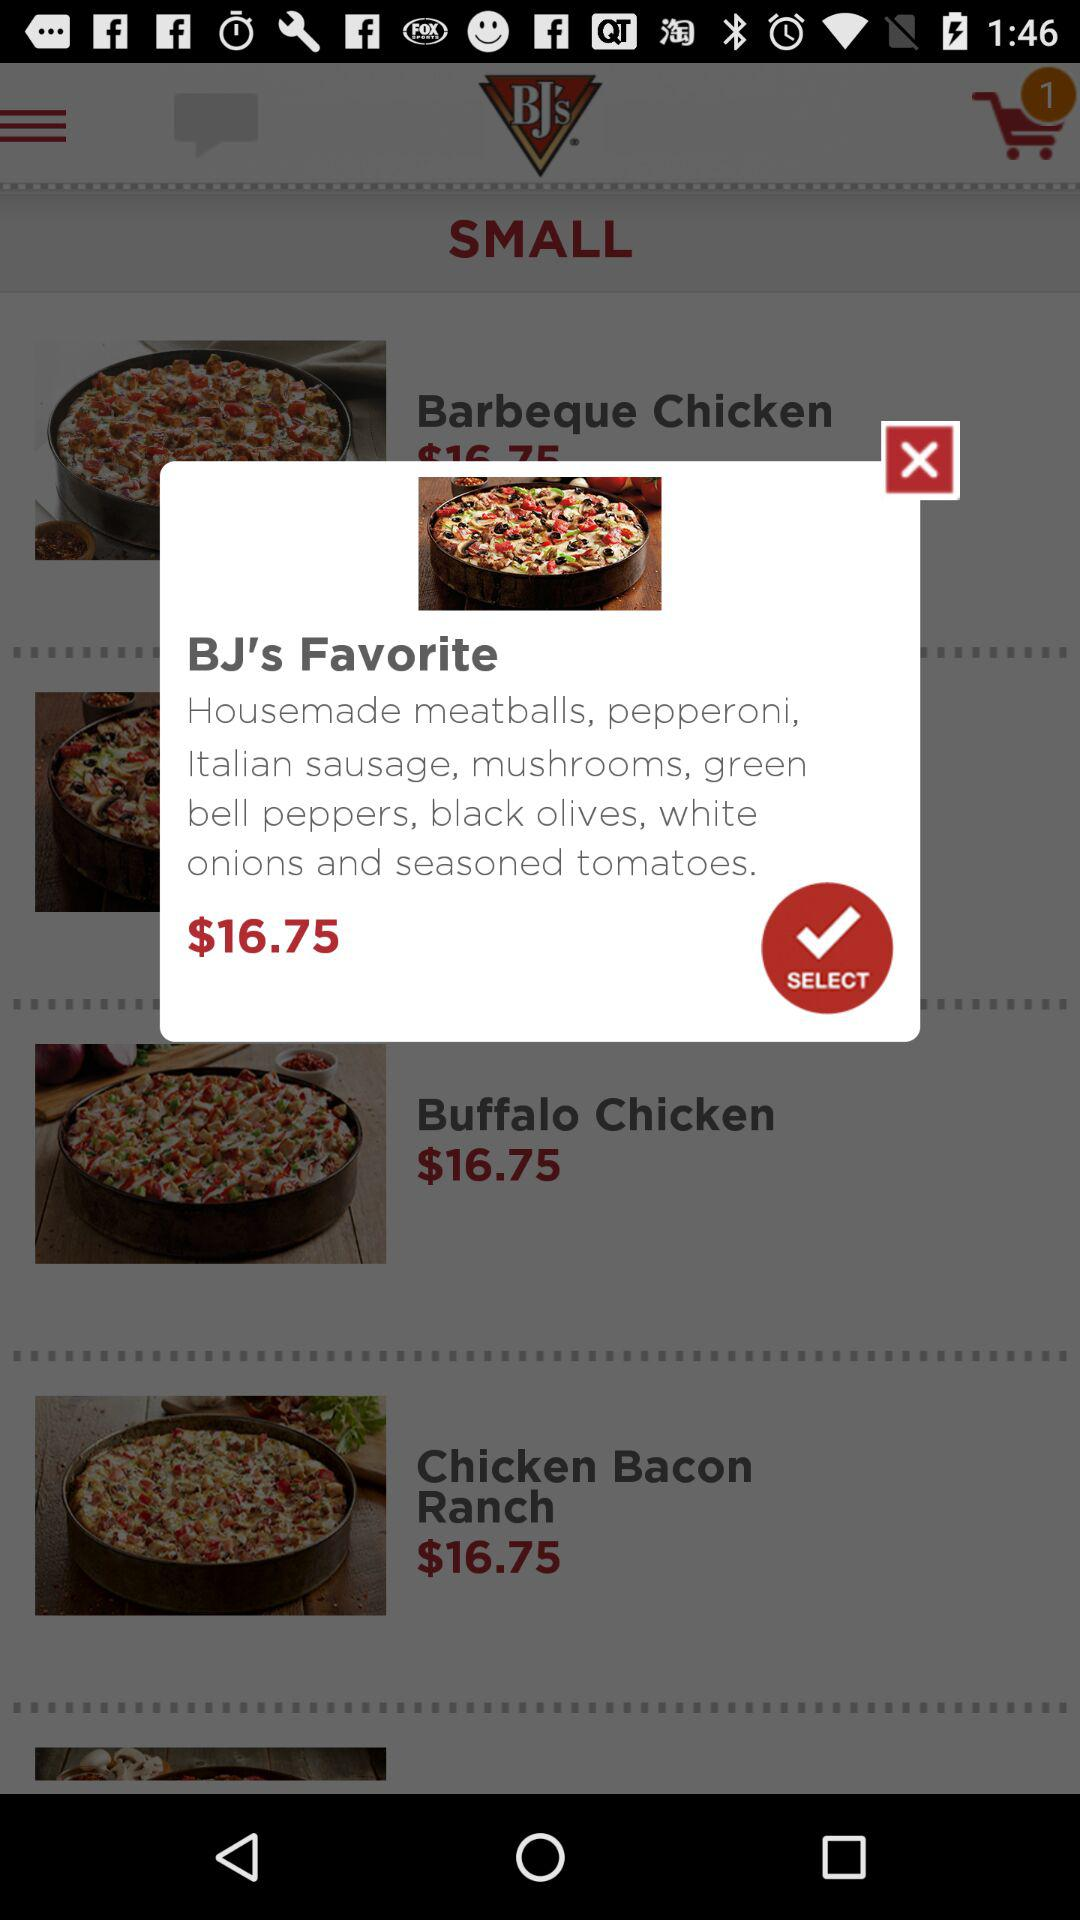How many toppings does the pizza have?
Answer the question using a single word or phrase. 8 